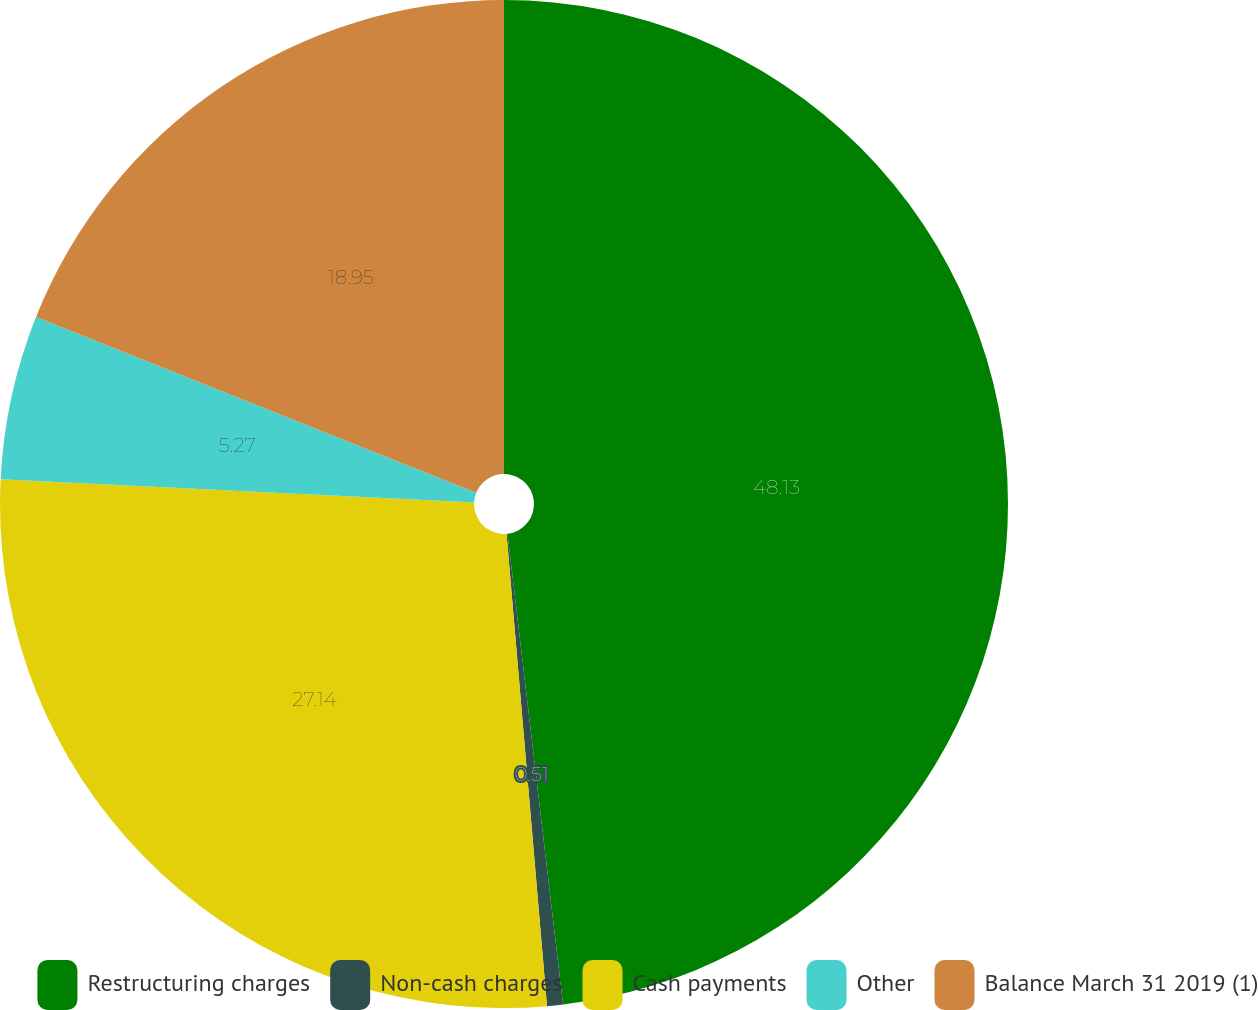Convert chart to OTSL. <chart><loc_0><loc_0><loc_500><loc_500><pie_chart><fcel>Restructuring charges<fcel>Non-cash charges<fcel>Cash payments<fcel>Other<fcel>Balance March 31 2019 (1)<nl><fcel>48.13%<fcel>0.51%<fcel>27.14%<fcel>5.27%<fcel>18.95%<nl></chart> 